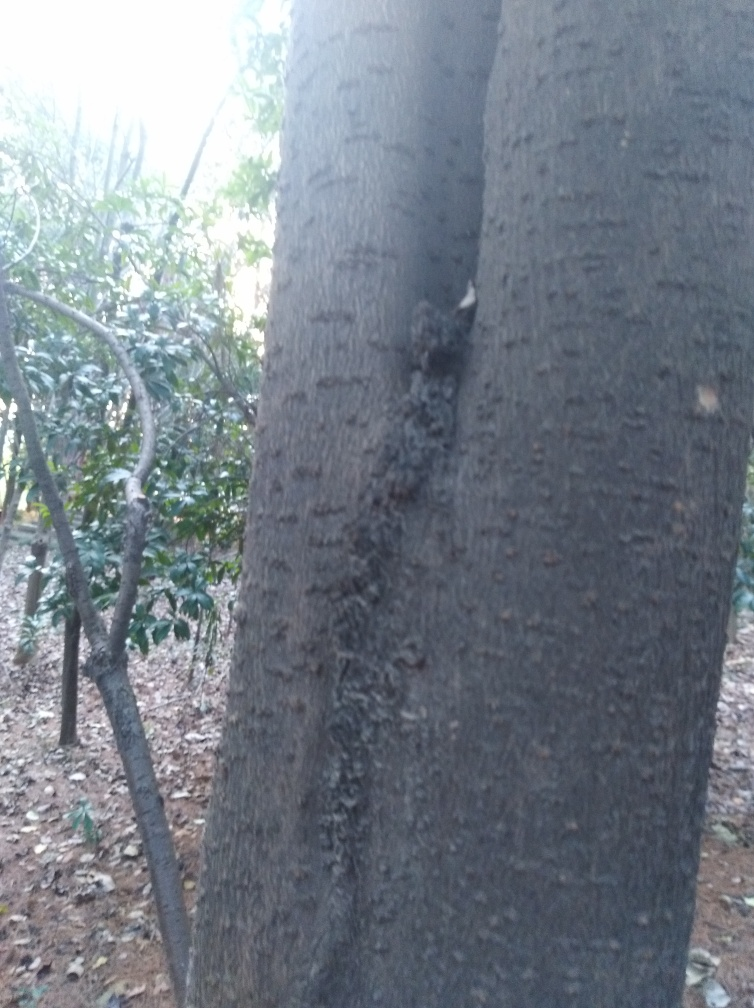Can you describe the types of trees or plants in the image? The image predominantly features a tree with dark bark that has deep vertical ridges, which could indicate it's a species of hardwood. In the background, there are hints of greenery suggesting the presence of bushes or smaller trees that are typically found in a wooded area or a park. 